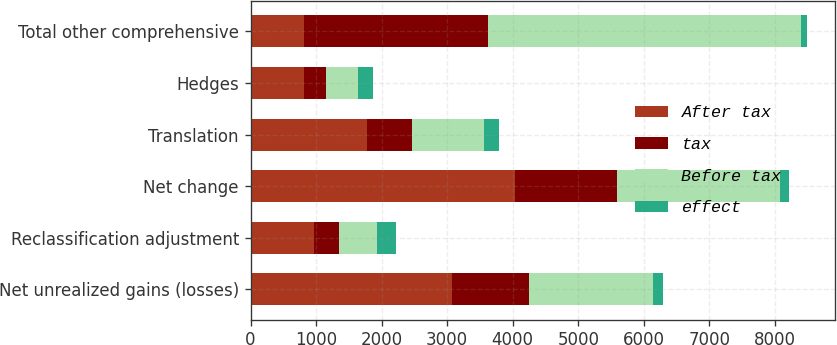Convert chart to OTSL. <chart><loc_0><loc_0><loc_500><loc_500><stacked_bar_chart><ecel><fcel>Net unrealized gains (losses)<fcel>Reclassification adjustment<fcel>Net change<fcel>Translation<fcel>Hedges<fcel>Total other comprehensive<nl><fcel>After tax<fcel>3071<fcel>965<fcel>4036<fcel>1781<fcel>820<fcel>820<nl><fcel>tax<fcel>1171<fcel>384<fcel>1555<fcel>682<fcel>327<fcel>2806<nl><fcel>Before tax<fcel>1900<fcel>581<fcel>2481<fcel>1099<fcel>493<fcel>4770<nl><fcel>effect<fcel>144<fcel>285<fcel>141<fcel>236<fcel>222<fcel>93<nl></chart> 